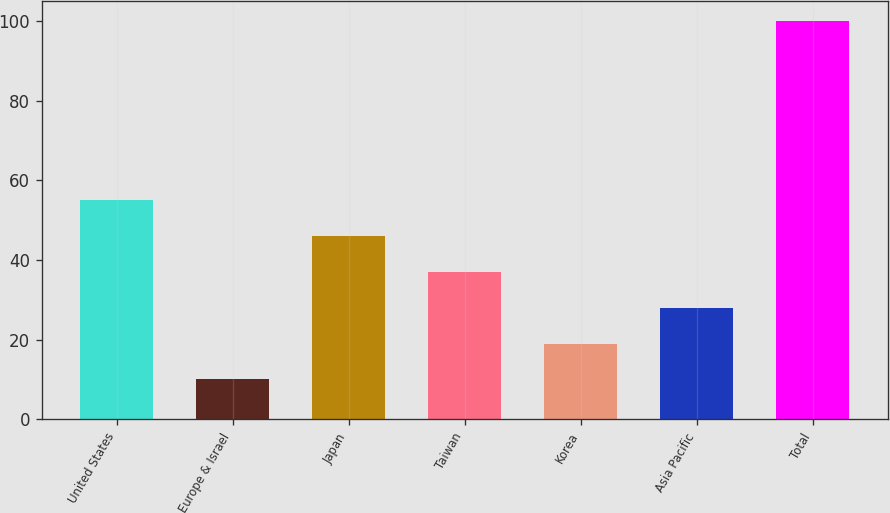<chart> <loc_0><loc_0><loc_500><loc_500><bar_chart><fcel>United States<fcel>Europe & Israel<fcel>Japan<fcel>Taiwan<fcel>Korea<fcel>Asia Pacific<fcel>Total<nl><fcel>55<fcel>10<fcel>46<fcel>37<fcel>19<fcel>28<fcel>100<nl></chart> 